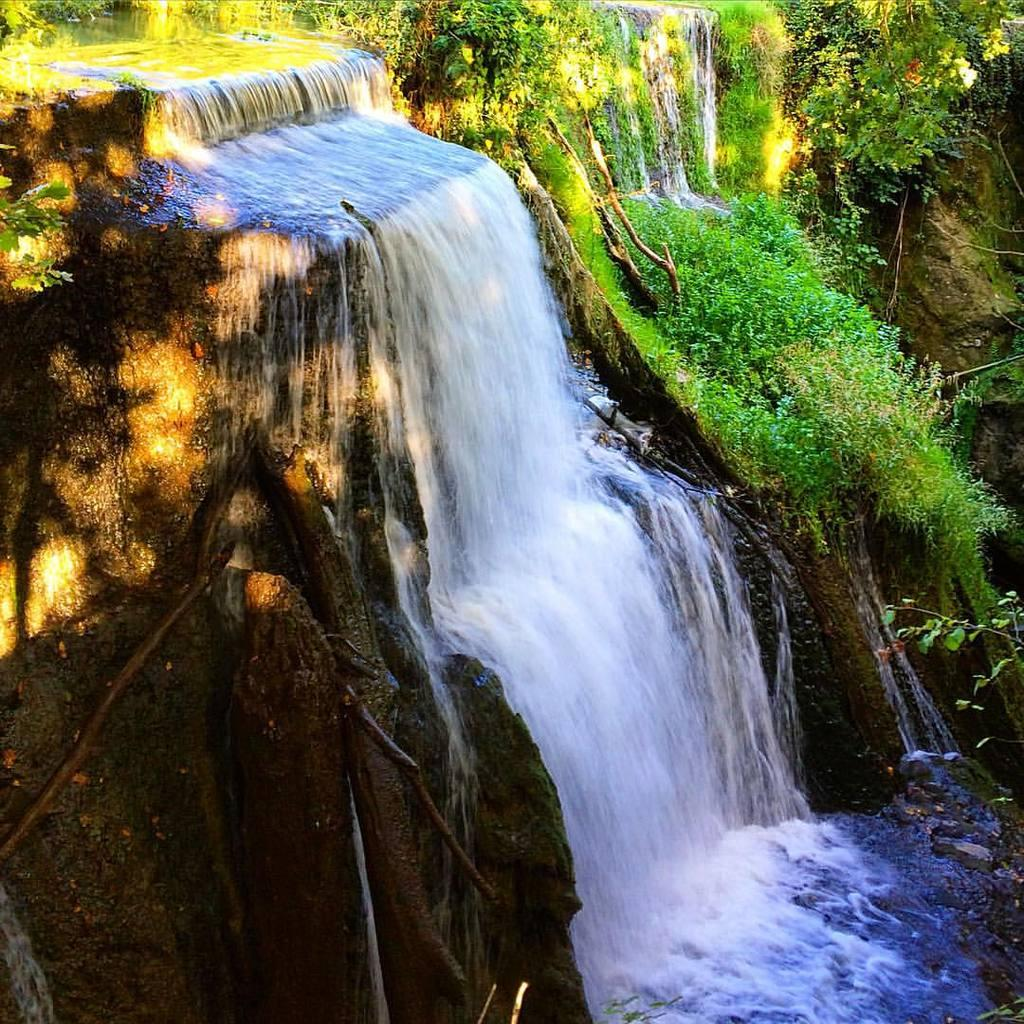What natural feature is the main subject of the image? There is a waterfall in the image. What type of vegetation can be seen in the image? There are trees in the image. Where is the bear in the image? There is no bear present in the image. What type of dust can be seen on the leaves of the trees in the image? There is no dust visible on the leaves of the trees in the image. 